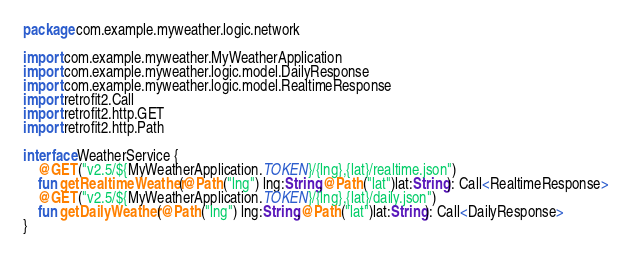Convert code to text. <code><loc_0><loc_0><loc_500><loc_500><_Kotlin_>package com.example.myweather.logic.network

import com.example.myweather.MyWeatherApplication
import com.example.myweather.logic.model.DailyResponse
import com.example.myweather.logic.model.RealtimeResponse
import retrofit2.Call
import retrofit2.http.GET
import retrofit2.http.Path

interface WeatherService {
    @GET("v2.5/${MyWeatherApplication.TOKEN}/{lng},{lat}/realtime.json")
    fun getRealtimeWeather(@Path("lng") lng:String,@Path("lat")lat:String): Call<RealtimeResponse>
    @GET("v2.5/${MyWeatherApplication.TOKEN}/{lng},{lat}/daily.json")
    fun getDailyWeather(@Path("lng") lng:String,@Path("lat")lat:String): Call<DailyResponse>
}</code> 